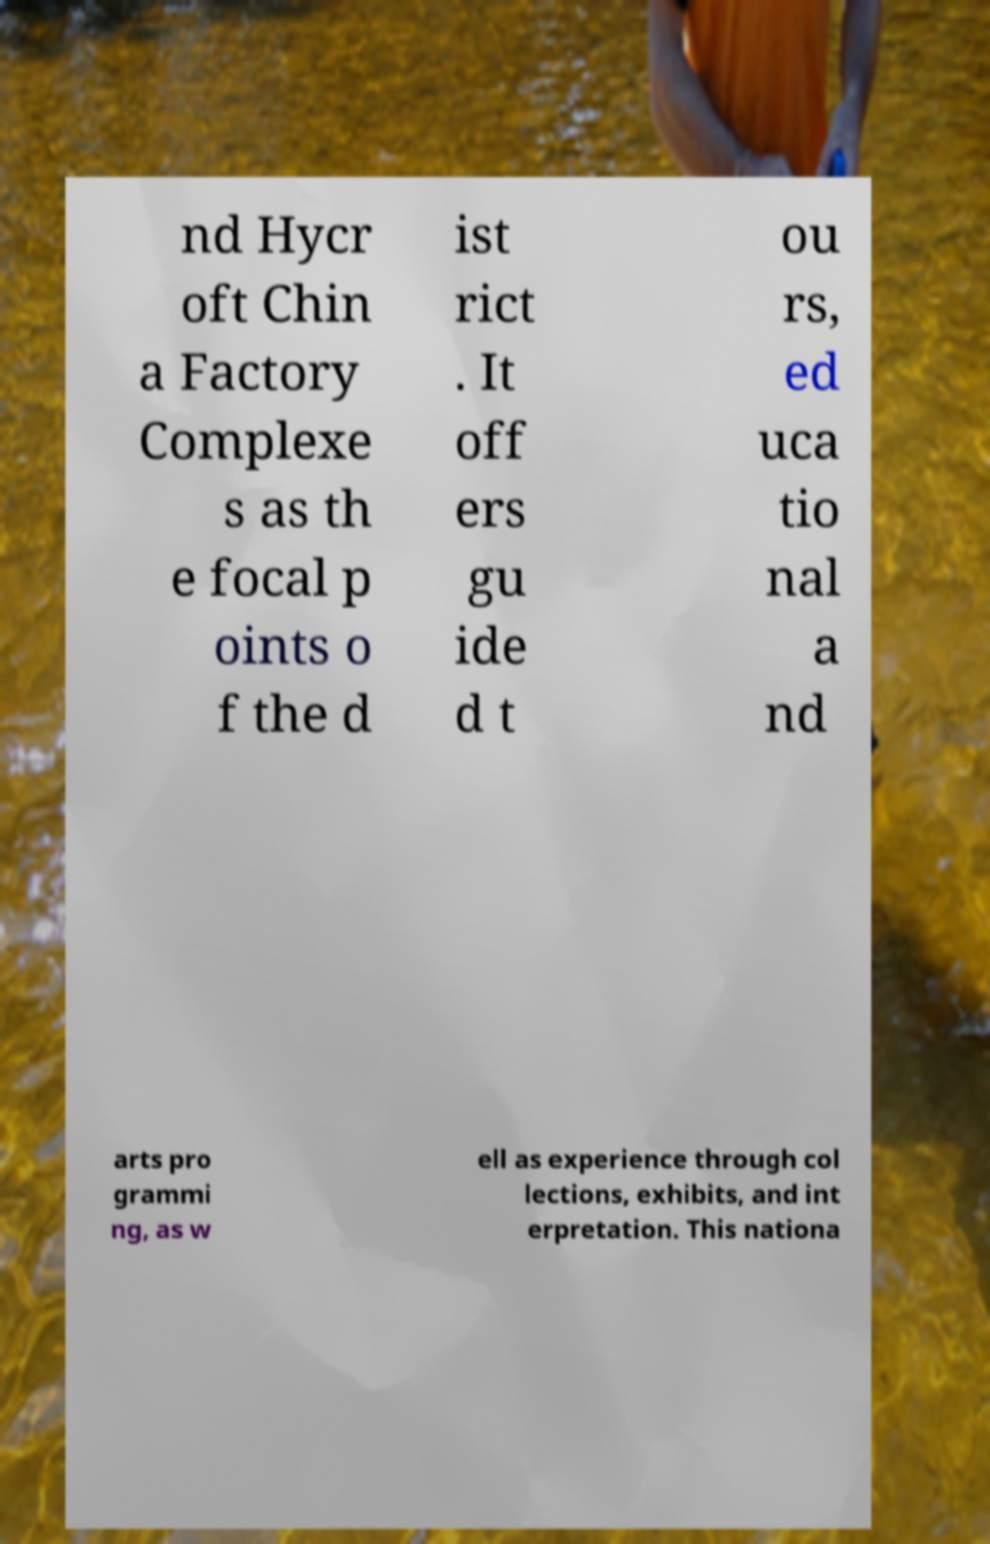For documentation purposes, I need the text within this image transcribed. Could you provide that? nd Hycr oft Chin a Factory Complexe s as th e focal p oints o f the d ist rict . It off ers gu ide d t ou rs, ed uca tio nal a nd arts pro grammi ng, as w ell as experience through col lections, exhibits, and int erpretation. This nationa 